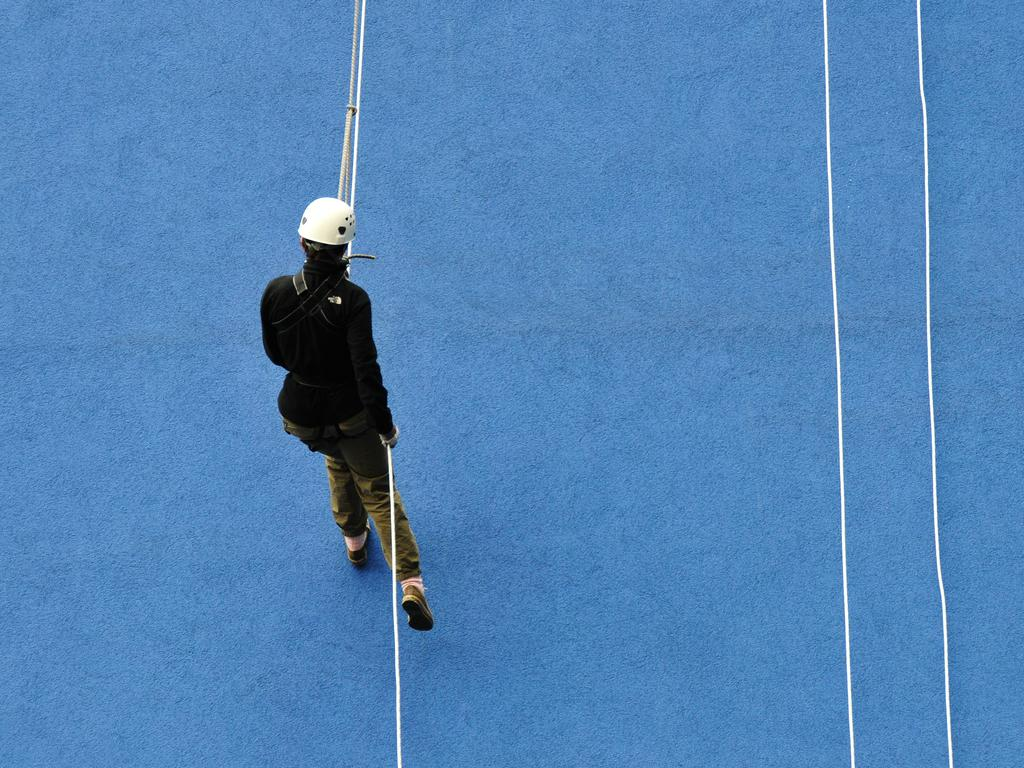What is the main subject of the image? There is a person in the image. What is the person doing in the image? The person is climbing a wall. What is the person using to assist in the climb? The person is holding a rope while climbing. Are there any other ropes visible in the image? Yes, there are two other ropes hanging beside the person. What shape is the corn taking in the image? There is no corn present in the image. What letters can be seen on the person's shirt in the image? The provided facts do not mention any letters or clothing details about the person in the image. 